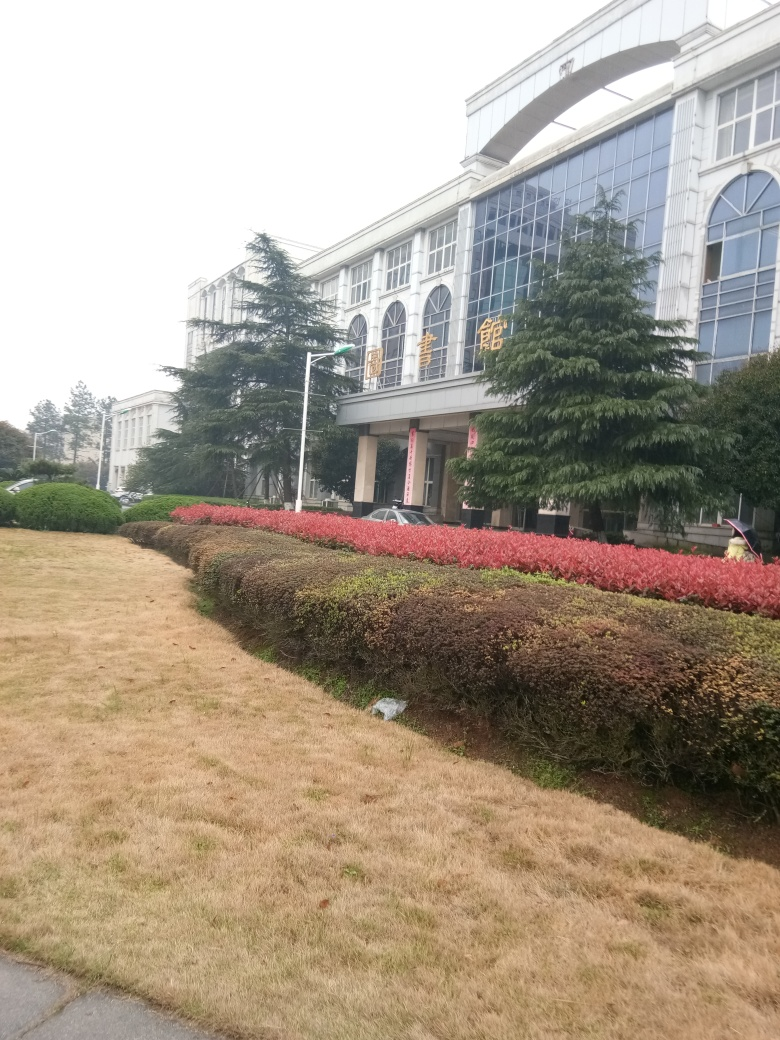Can you describe the landscaping seen in the image? In the image, the landscaping includes a well-manicured lawn that appears to be suffering from a lack of water, as indicated by the brown patches. There's also a row of trimmed hedges with red foliage, providing a pop of color and a sense of order to the setting. 